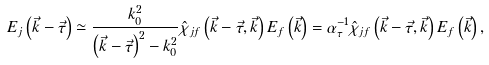Convert formula to latex. <formula><loc_0><loc_0><loc_500><loc_500>E _ { j } \left ( \vec { k } - \vec { \tau } \right ) \simeq \frac { k _ { 0 } ^ { 2 } } { \left ( \vec { k } - \vec { \tau } \right ) ^ { 2 } - k _ { 0 } ^ { 2 } } \hat { \chi } _ { j f } \left ( \vec { k } - \vec { \tau } , \vec { k } \right ) E _ { f } \left ( \vec { k } \right ) = \alpha _ { \tau } ^ { - 1 } \hat { \chi } _ { j f } \left ( \vec { k } - \vec { \tau } , \vec { k } \right ) E _ { f } \left ( \vec { k } \right ) ,</formula> 